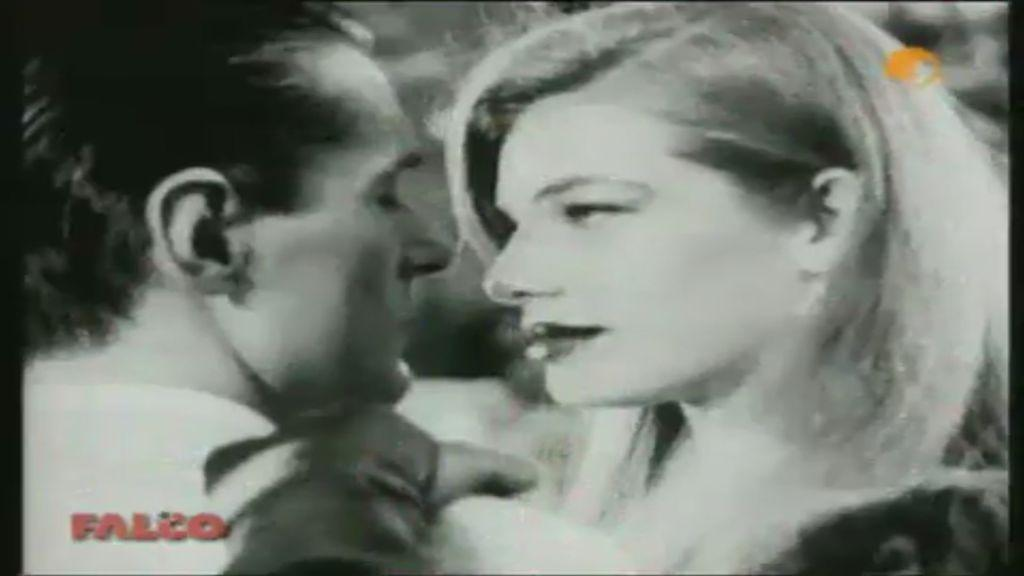What is the color scheme of the image? The image is black and white. What people can be seen in the image? There is a man and a woman in the image. What type of design can be seen on the kitty's fur in the image? There is no kitty present in the image, so there is no design on its fur to observe. 